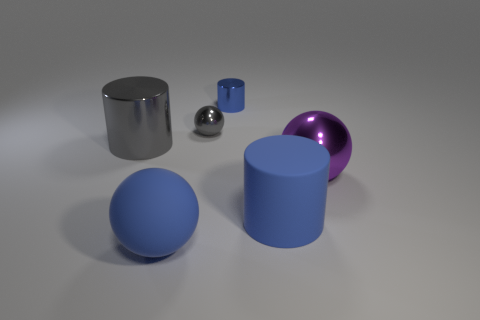Add 1 tiny metallic things. How many objects exist? 7 Subtract all blue matte cylinders. How many cylinders are left? 2 Subtract all purple cubes. How many blue cylinders are left? 2 Subtract all gray cylinders. How many cylinders are left? 2 Subtract 0 green spheres. How many objects are left? 6 Subtract 3 spheres. How many spheres are left? 0 Subtract all red cylinders. Subtract all brown blocks. How many cylinders are left? 3 Subtract all blue metallic balls. Subtract all balls. How many objects are left? 3 Add 6 small cylinders. How many small cylinders are left? 7 Add 1 tiny gray balls. How many tiny gray balls exist? 2 